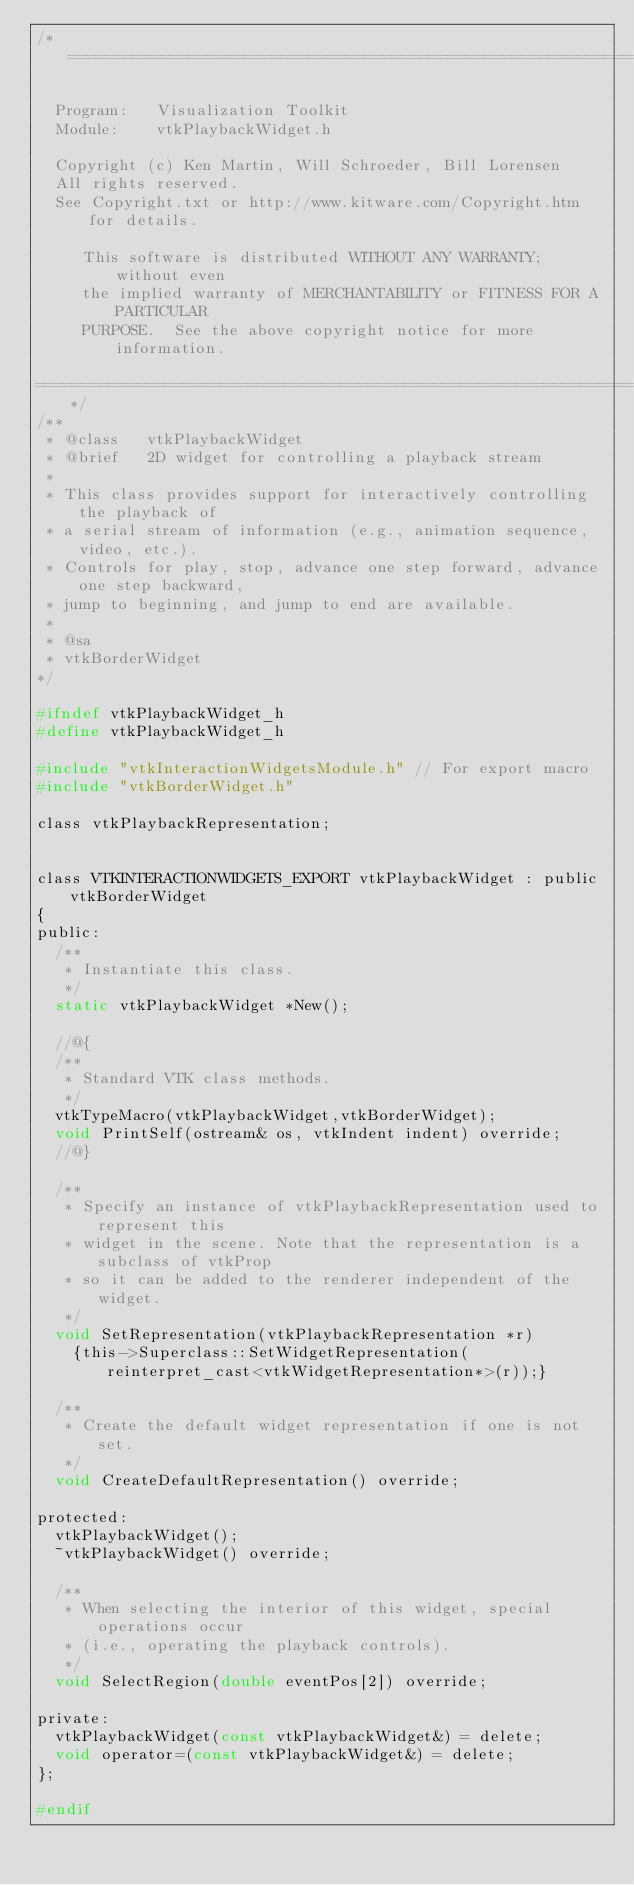Convert code to text. <code><loc_0><loc_0><loc_500><loc_500><_C_>/*=========================================================================

  Program:   Visualization Toolkit
  Module:    vtkPlaybackWidget.h

  Copyright (c) Ken Martin, Will Schroeder, Bill Lorensen
  All rights reserved.
  See Copyright.txt or http://www.kitware.com/Copyright.htm for details.

     This software is distributed WITHOUT ANY WARRANTY; without even
     the implied warranty of MERCHANTABILITY or FITNESS FOR A PARTICULAR
     PURPOSE.  See the above copyright notice for more information.

=========================================================================*/
/**
 * @class   vtkPlaybackWidget
 * @brief   2D widget for controlling a playback stream
 *
 * This class provides support for interactively controlling the playback of
 * a serial stream of information (e.g., animation sequence, video, etc.).
 * Controls for play, stop, advance one step forward, advance one step backward,
 * jump to beginning, and jump to end are available.
 *
 * @sa
 * vtkBorderWidget
*/

#ifndef vtkPlaybackWidget_h
#define vtkPlaybackWidget_h

#include "vtkInteractionWidgetsModule.h" // For export macro
#include "vtkBorderWidget.h"

class vtkPlaybackRepresentation;


class VTKINTERACTIONWIDGETS_EXPORT vtkPlaybackWidget : public vtkBorderWidget
{
public:
  /**
   * Instantiate this class.
   */
  static vtkPlaybackWidget *New();

  //@{
  /**
   * Standard VTK class methods.
   */
  vtkTypeMacro(vtkPlaybackWidget,vtkBorderWidget);
  void PrintSelf(ostream& os, vtkIndent indent) override;
  //@}

  /**
   * Specify an instance of vtkPlaybackRepresentation used to represent this
   * widget in the scene. Note that the representation is a subclass of vtkProp
   * so it can be added to the renderer independent of the widget.
   */
  void SetRepresentation(vtkPlaybackRepresentation *r)
    {this->Superclass::SetWidgetRepresentation(reinterpret_cast<vtkWidgetRepresentation*>(r));}

  /**
   * Create the default widget representation if one is not set.
   */
  void CreateDefaultRepresentation() override;

protected:
  vtkPlaybackWidget();
  ~vtkPlaybackWidget() override;

  /**
   * When selecting the interior of this widget, special operations occur
   * (i.e., operating the playback controls).
   */
  void SelectRegion(double eventPos[2]) override;

private:
  vtkPlaybackWidget(const vtkPlaybackWidget&) = delete;
  void operator=(const vtkPlaybackWidget&) = delete;
};

#endif
</code> 